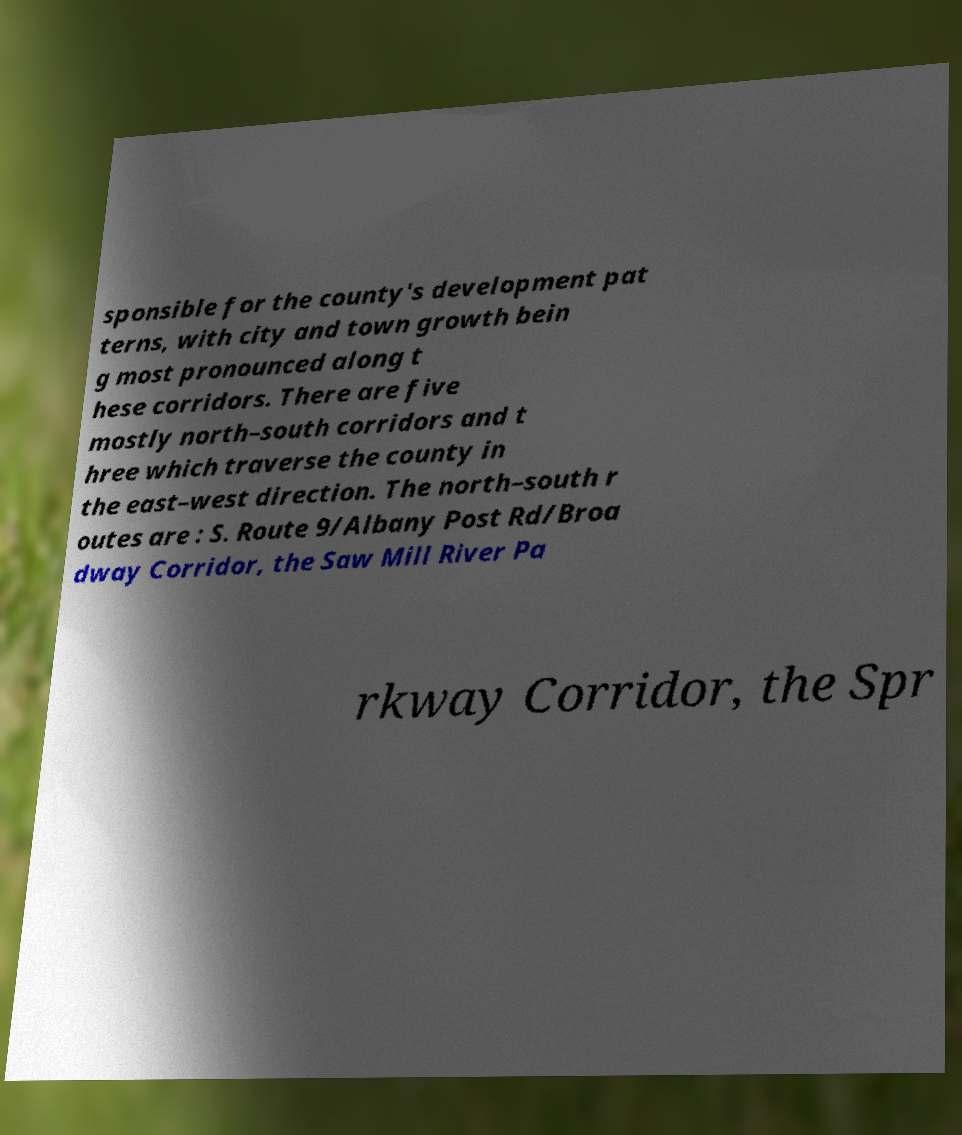Please identify and transcribe the text found in this image. sponsible for the county's development pat terns, with city and town growth bein g most pronounced along t hese corridors. There are five mostly north–south corridors and t hree which traverse the county in the east–west direction. The north–south r outes are : S. Route 9/Albany Post Rd/Broa dway Corridor, the Saw Mill River Pa rkway Corridor, the Spr 